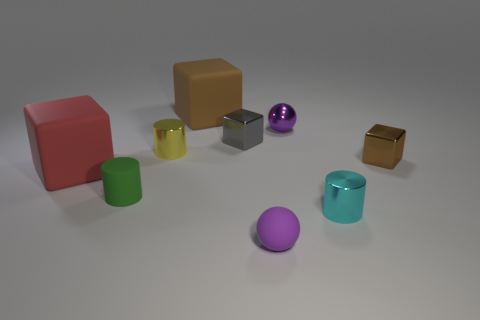Are there any objects with reflective surfaces in the image? Yes, the image features several objects with reflective surfaces. Specifically, the silver cube in the center, the small metallic purple sphere to the right, and the golden-yellow box to the far right all have surfaces that exhibit reflectivity. 